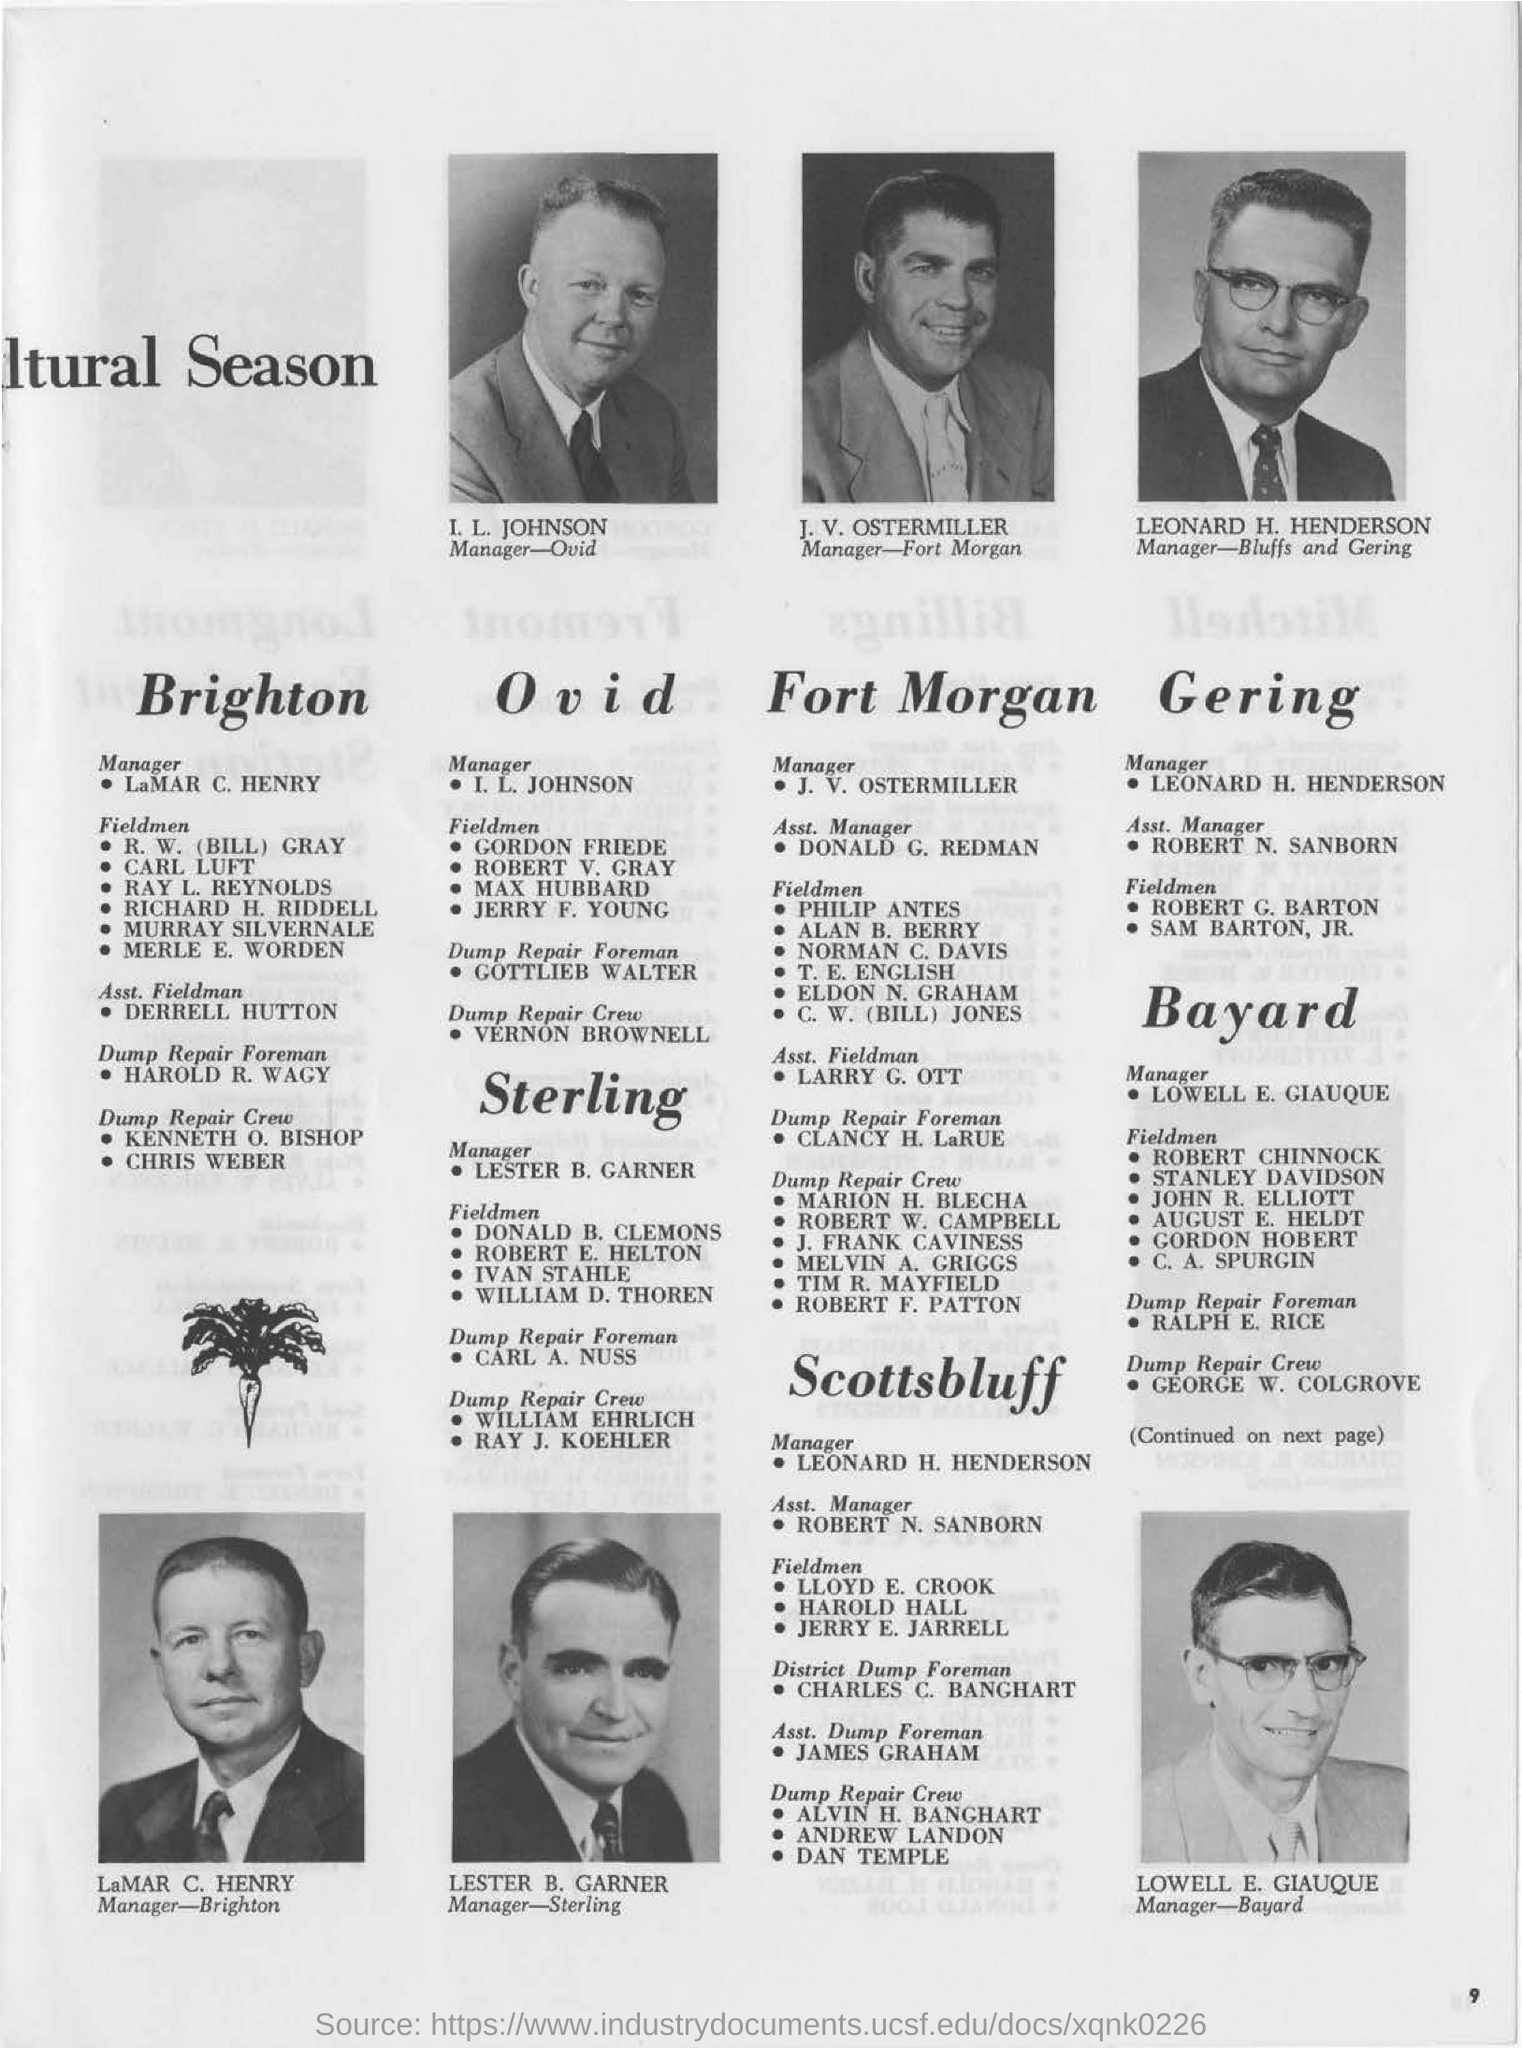Lester B. Garner is manager for which one?
Your response must be concise. Sterling. Who is the manager for ovid?
Give a very brief answer. I. L. JOHNSON. 